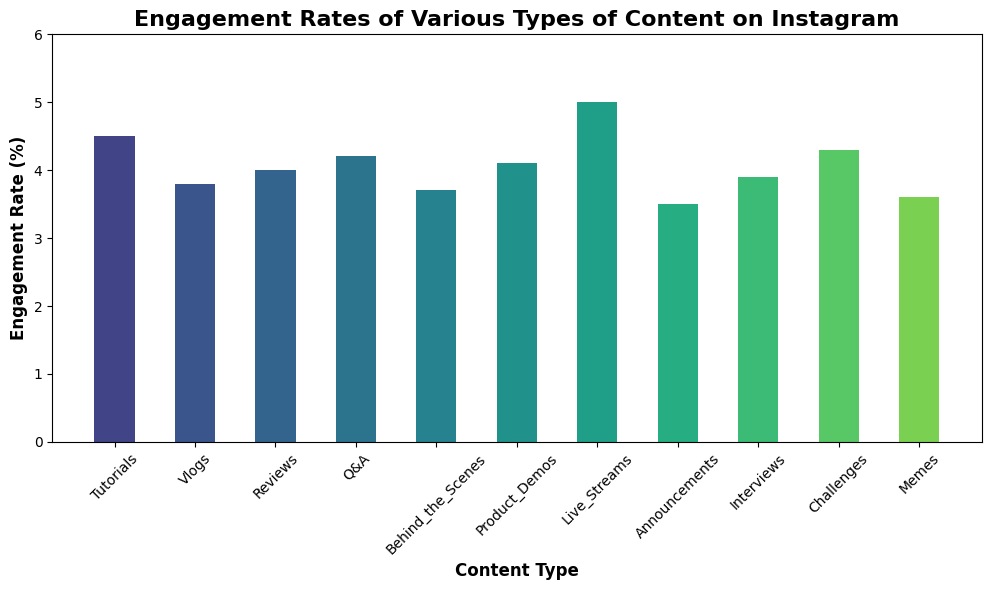What type of content has the highest engagement rate? The bar for "Live Streams" is the tallest among all content types, indicating it has the highest engagement rate.
Answer: Live Streams What type of content has the lowest engagement rate? The bar for "Announcements" is the shortest, indicating it has the lowest engagement rate.
Answer: Announcements How much higher is the engagement rate for Live Streams compared to Vlogs? The engagement rate for Live Streams is 5.0, and for Vlogs, it is 3.8. The difference is calculated as 5.0 - 3.8 = 1.2.
Answer: 1.2 Which content types have engagement rates higher than 4.0? The bars for "Live Streams", "Challenges", "Q&A", "Tutorials", "Product Demos", and "Reviews" all exceed the 4.0 mark.
Answer: Live Streams, Challenges, Q&A, Tutorials, Product Demos, Reviews Between Interviews and Behind the Scenes, which has a higher engagement rate? The bar for "Interviews" is taller than the bar for "Behind the Scenes", indicating a higher engagement rate.
Answer: Interviews What is the average engagement rate of all content types? To find the average, sum all engagement rates: 4.5 + 3.8 + 4.0 + 4.2 + 3.7 + 4.1 + 5.0 + 3.5 + 3.9 + 4.3 + 3.6 = 44.6. Then, divide by the number of content types, which is 11. So, 44.6 / 11 ≈ 4.05.
Answer: 4.05 Which content type has an engagement rate closest to the overall average engagement rate? The overall average engagement rate is approximately 4.05. The engagement rates nearest to this value are "Reviews" and "Product Demos", both with rates of 4.0 and 4.1 respectively.
Answer: Reviews, Product Demos What is the total engagement rate for Tutorials, Q&A, and Challenges combined? Sum the engagement rates: Tutorials (4.5) + Q&A (4.2) + Challenges (4.3) = 4.5 + 4.2 + 4.3 = 13.0.
Answer: 13.0 